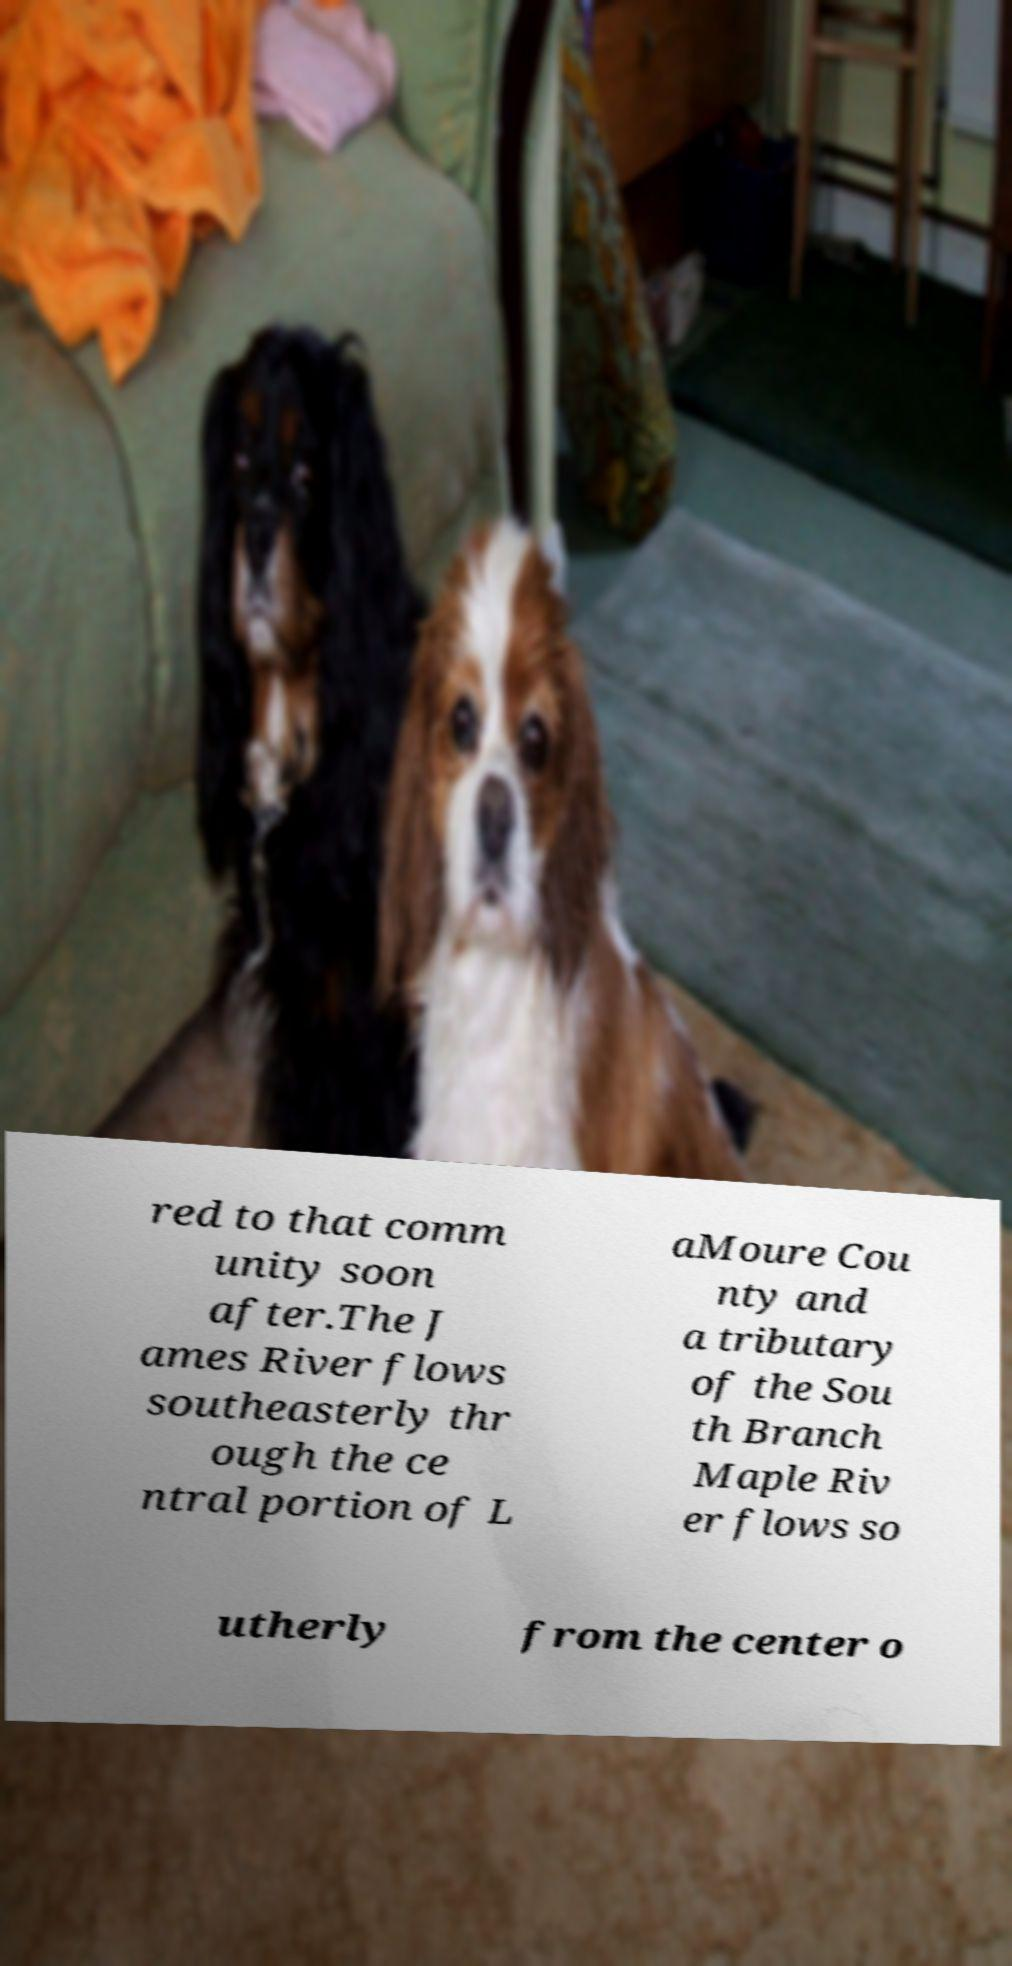Please identify and transcribe the text found in this image. red to that comm unity soon after.The J ames River flows southeasterly thr ough the ce ntral portion of L aMoure Cou nty and a tributary of the Sou th Branch Maple Riv er flows so utherly from the center o 